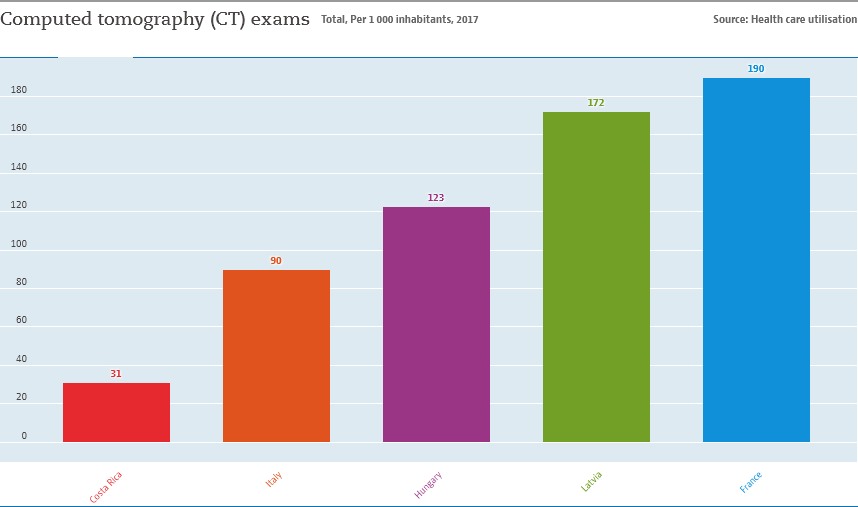Outline some significant characteristics in this image. The difference in value between France and Latvia is 18 times. The value of 90 represents the place of Italy. 